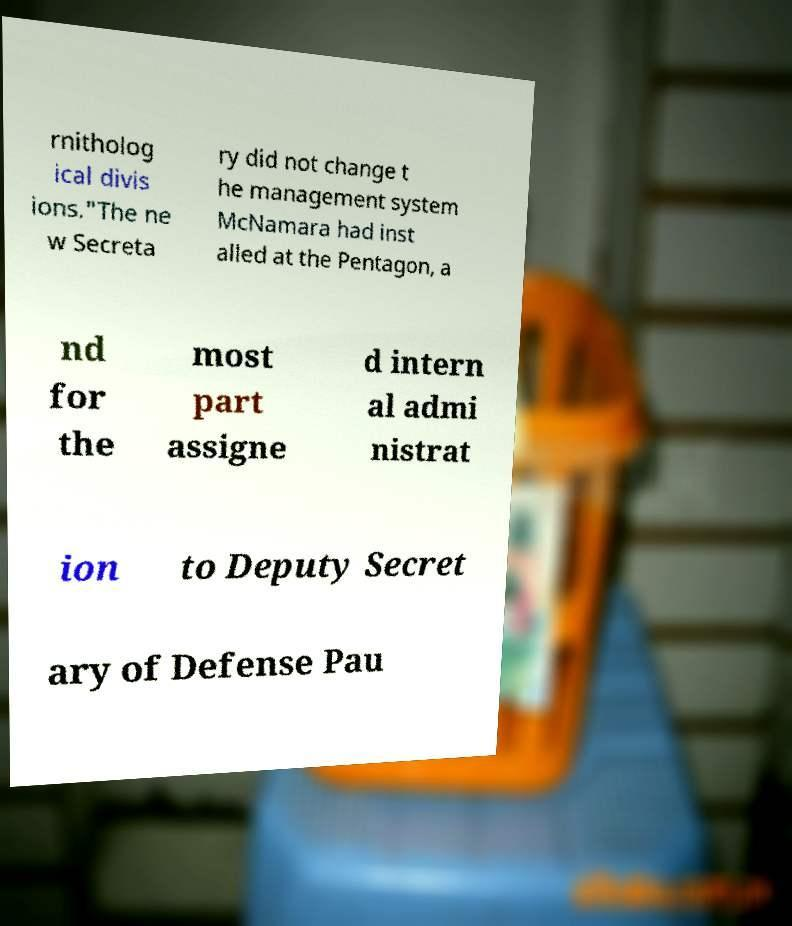There's text embedded in this image that I need extracted. Can you transcribe it verbatim? rnitholog ical divis ions."The ne w Secreta ry did not change t he management system McNamara had inst alled at the Pentagon, a nd for the most part assigne d intern al admi nistrat ion to Deputy Secret ary of Defense Pau 